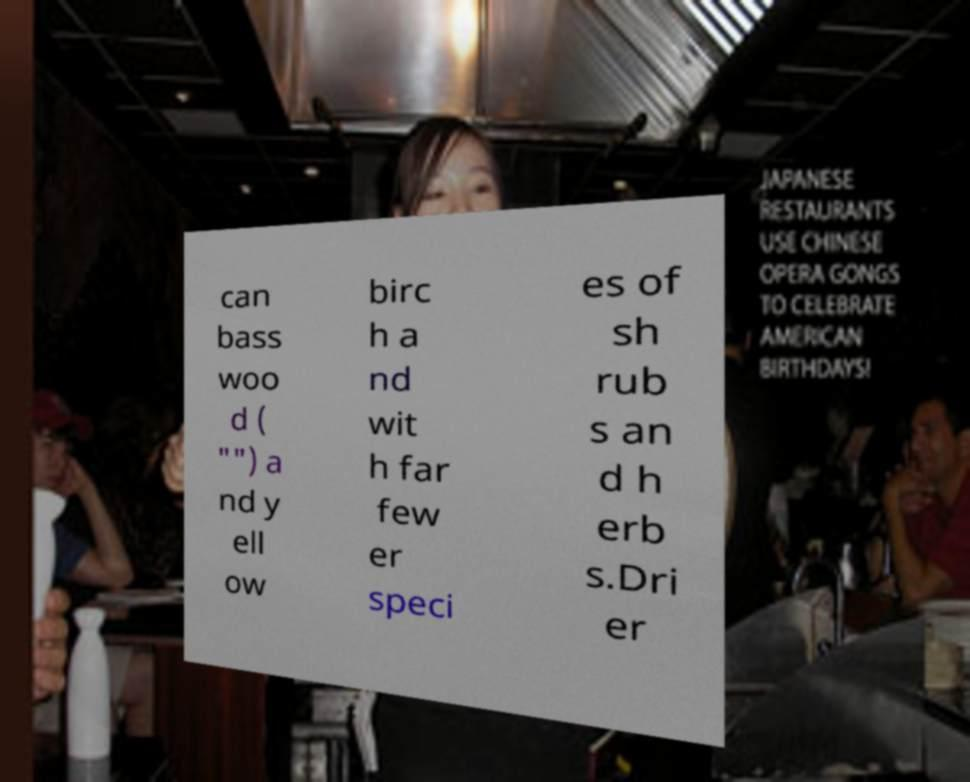I need the written content from this picture converted into text. Can you do that? can bass woo d ( "") a nd y ell ow birc h a nd wit h far few er speci es of sh rub s an d h erb s.Dri er 